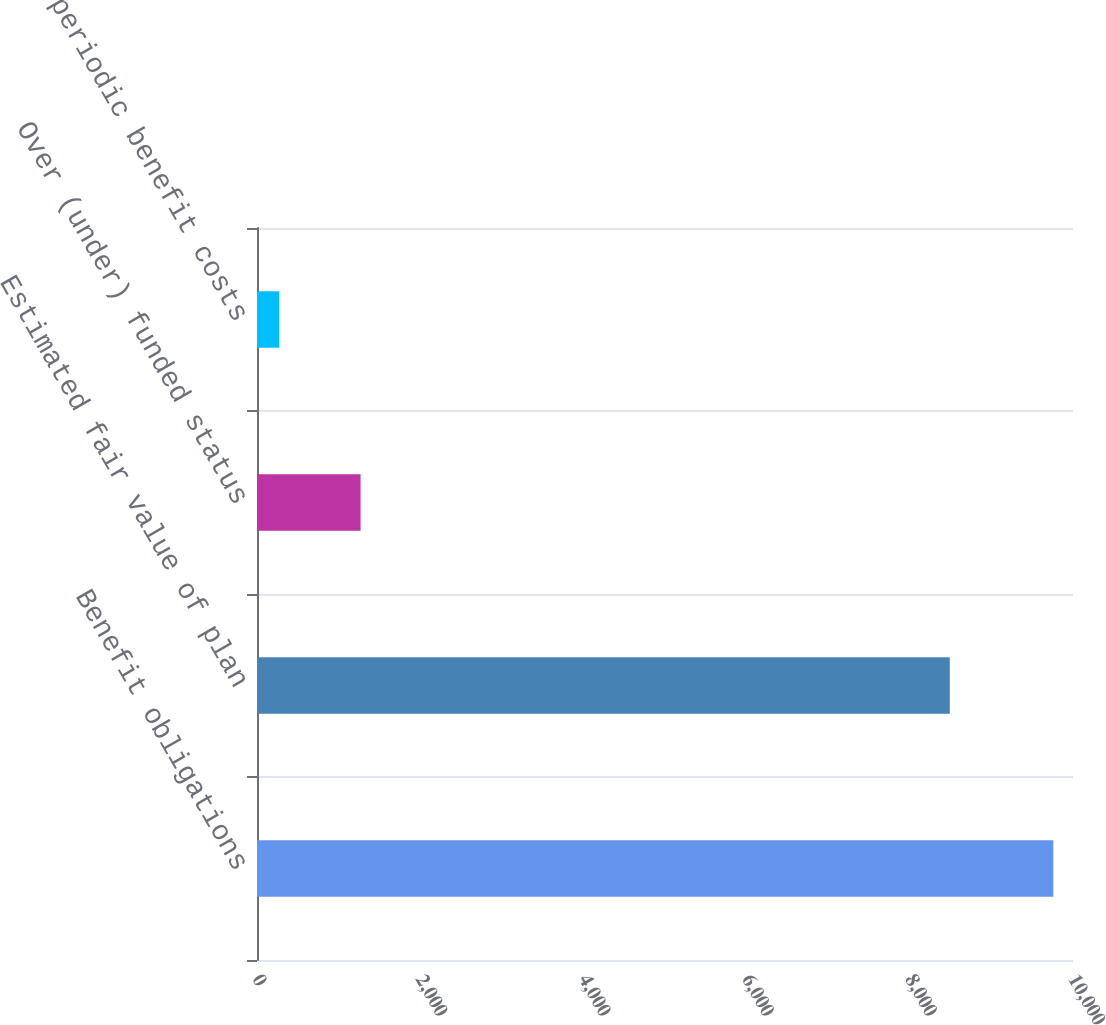Convert chart to OTSL. <chart><loc_0><loc_0><loc_500><loc_500><bar_chart><fcel>Benefit obligations<fcel>Estimated fair value of plan<fcel>Over (under) funded status<fcel>Net periodic benefit costs<nl><fcel>9759<fcel>8490<fcel>1269<fcel>273<nl></chart> 